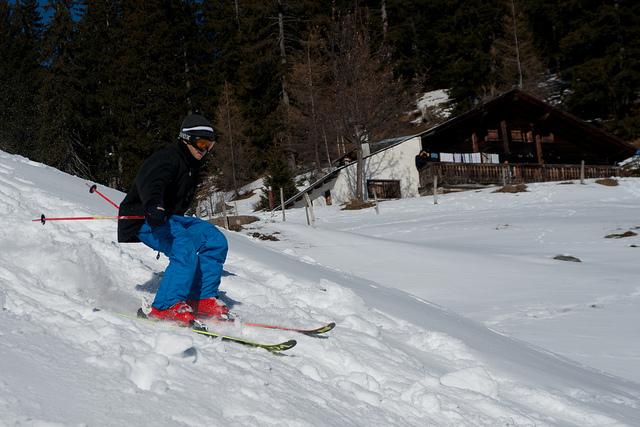Is this  a summer sport?
Give a very brief answer. No. What color are his ski boats?
Keep it brief. Red. What is the man doing?
Quick response, please. Skiing. 